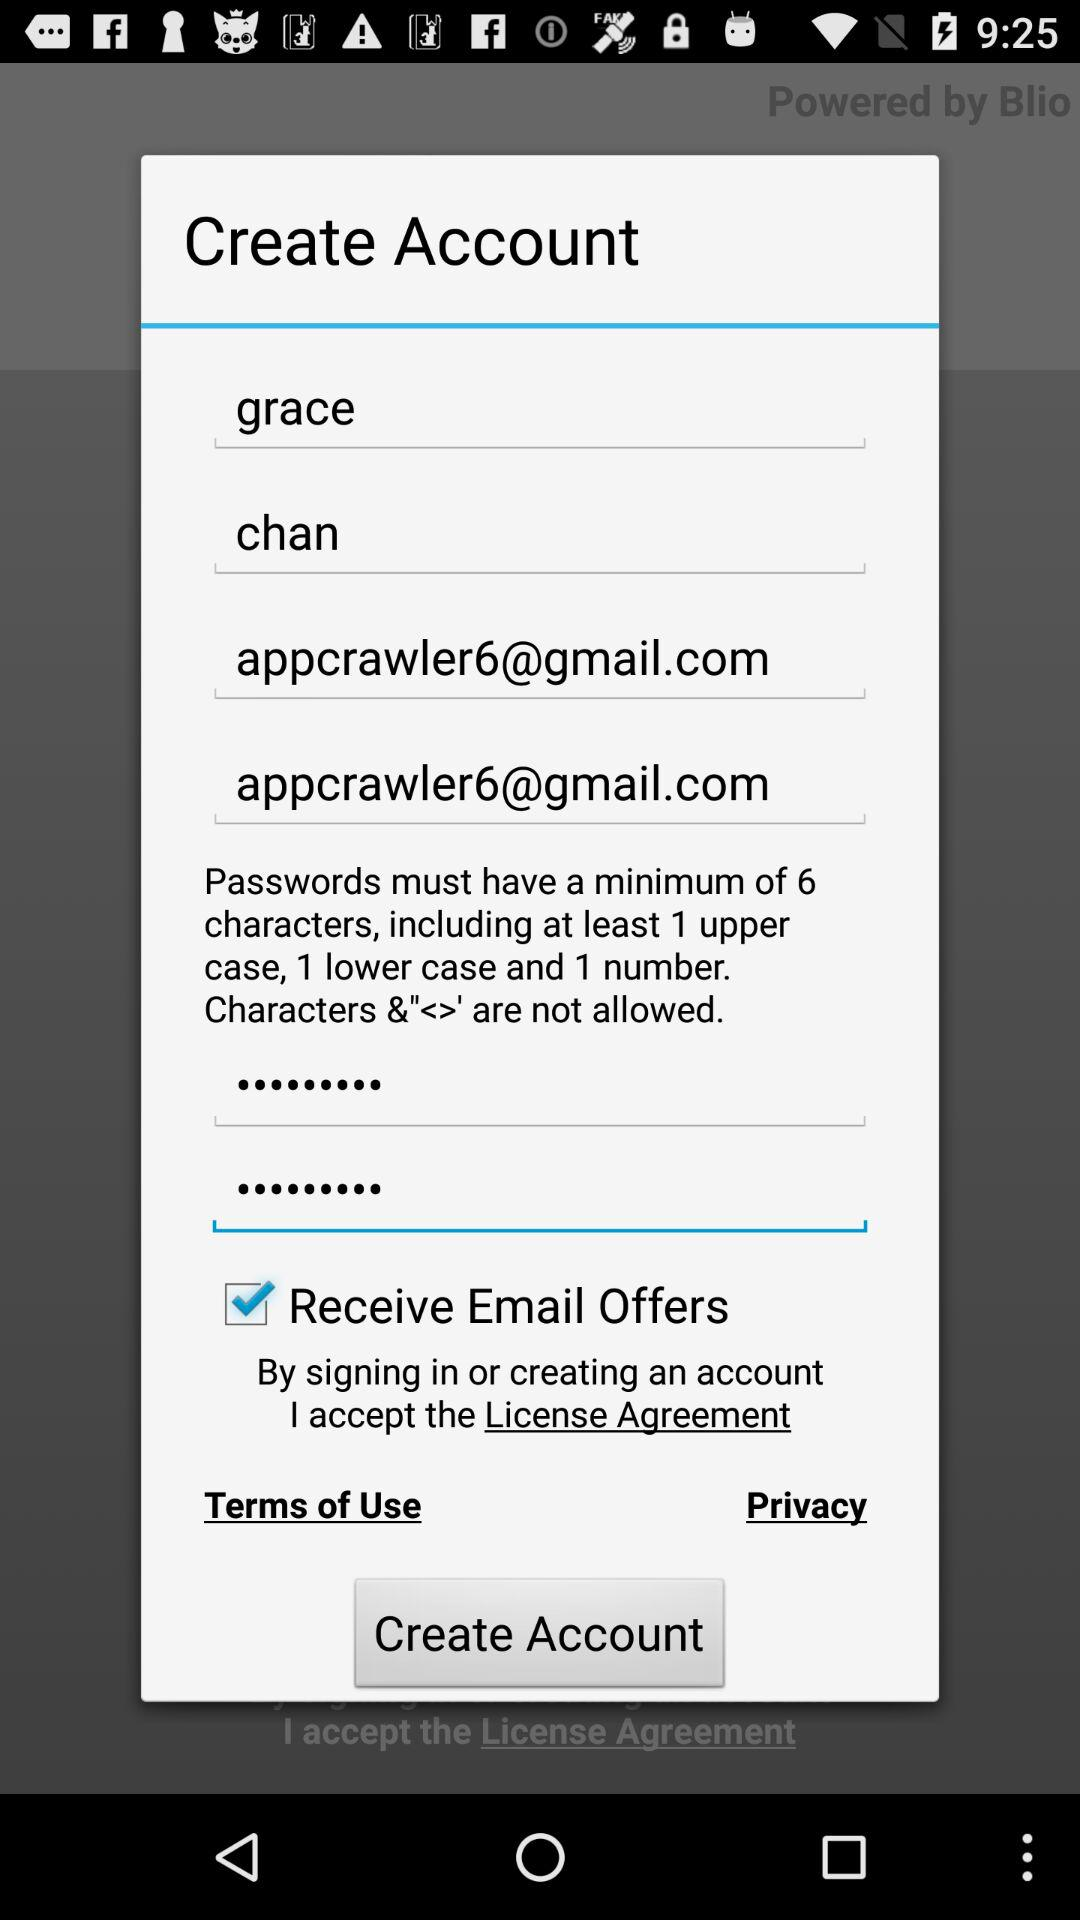Which option is marked checked? The option is "Receive Email Offers". 